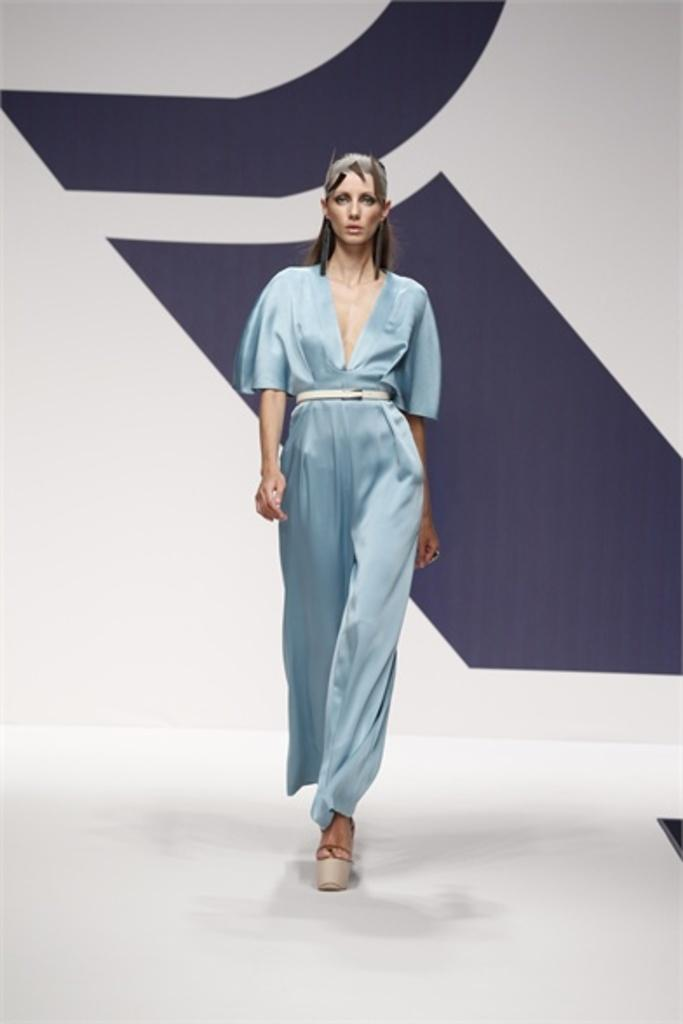What is the main subject of the image? The main subject of the image is a woman model. What is the woman model wearing? The woman model is wearing a blue dress. What is the woman model doing in the image? The woman model is walking in the image. What can be seen in the background of the image? There is a white color wall and a blue color print on the wall in the background of the image. What type of cheese is the secretary holding in the image? There is no secretary or cheese present in the image. Is the tiger in the image trying to catch the woman model? There is no tiger present in the image. 